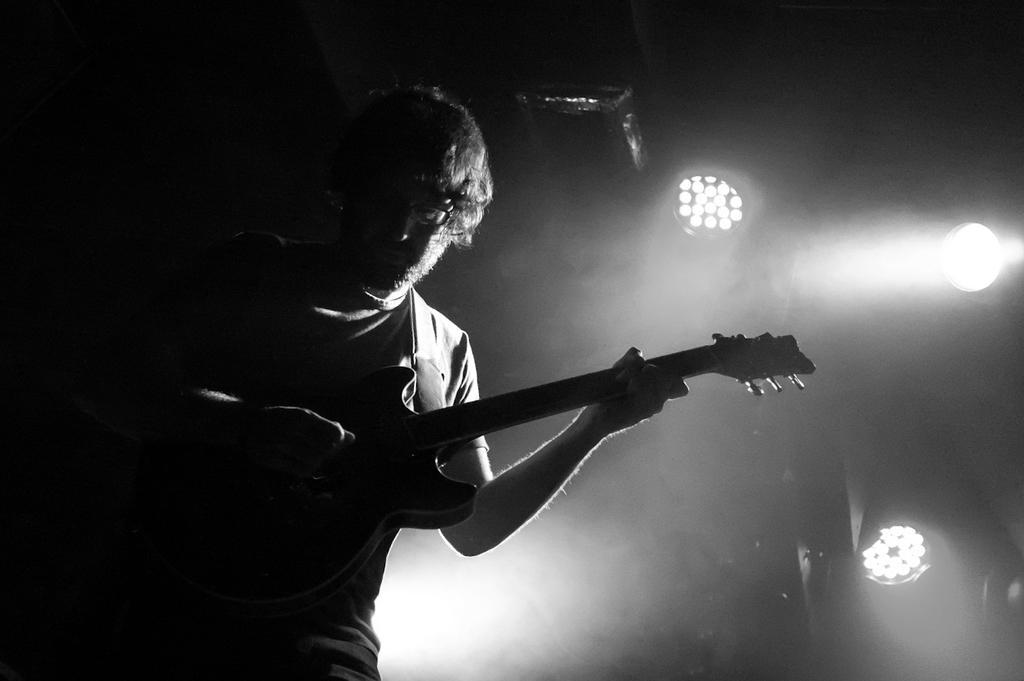In one or two sentences, can you explain what this image depicts? One person is playing a guitar and wearing glasses and behind him there are lights and projector in the picture. 